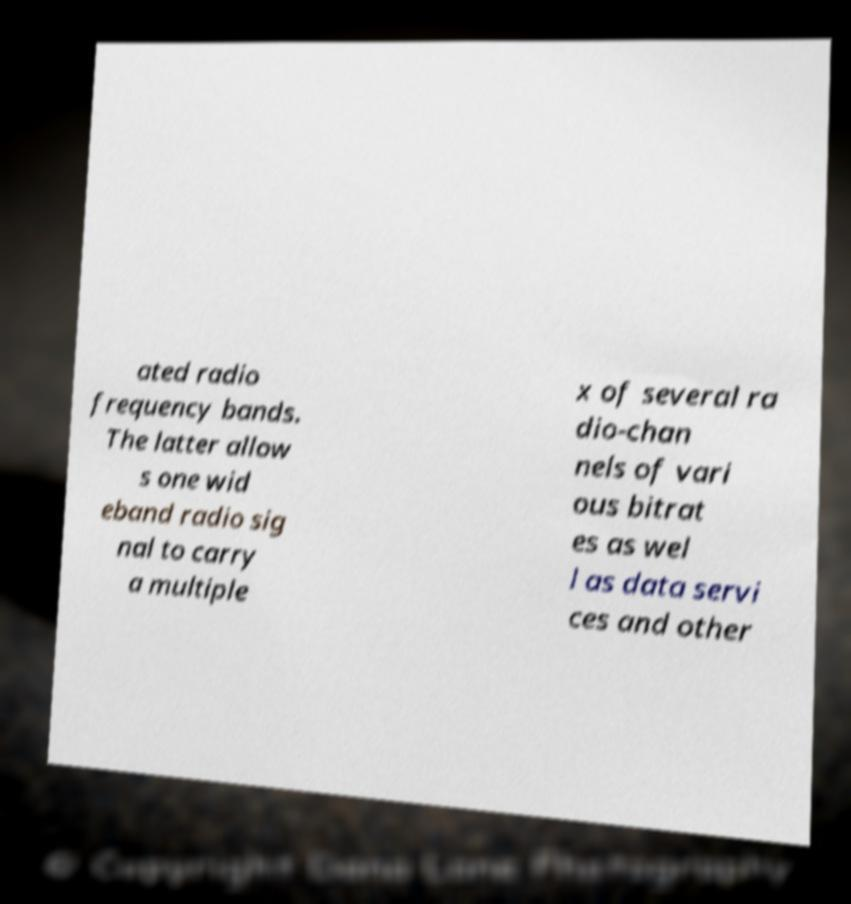Can you accurately transcribe the text from the provided image for me? ated radio frequency bands. The latter allow s one wid eband radio sig nal to carry a multiple x of several ra dio-chan nels of vari ous bitrat es as wel l as data servi ces and other 